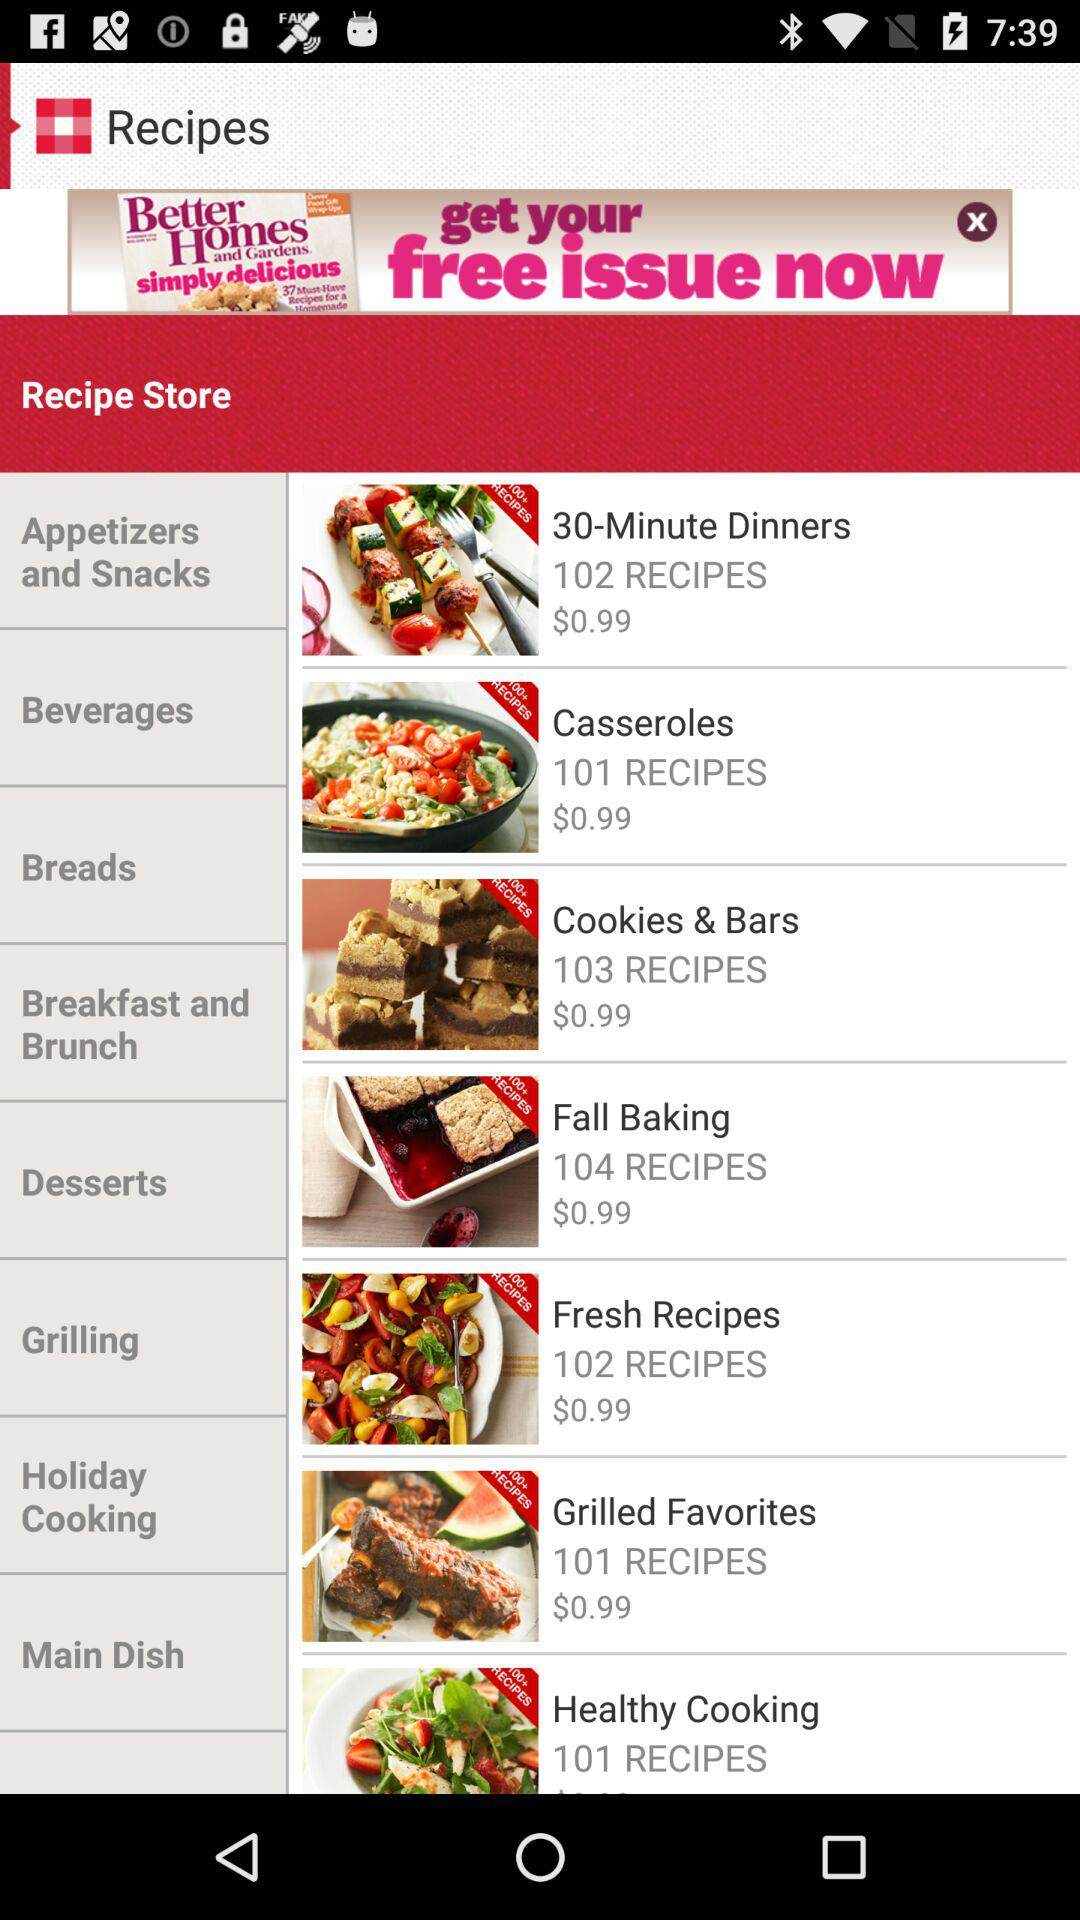What is the number of recipes in "Cookies and Bars"? There are 103 recipes in "Cookies and Bars". 